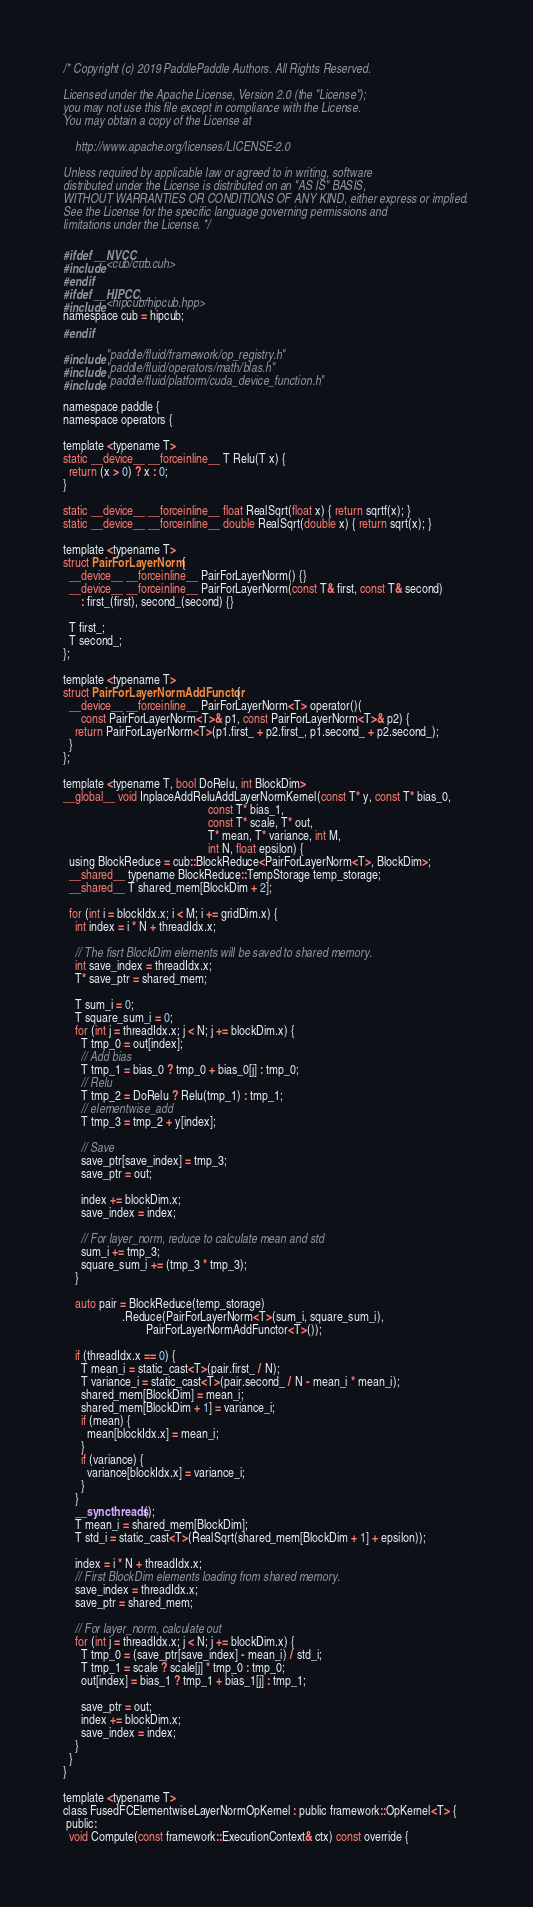<code> <loc_0><loc_0><loc_500><loc_500><_Cuda_>/* Copyright (c) 2019 PaddlePaddle Authors. All Rights Reserved.

Licensed under the Apache License, Version 2.0 (the "License");
you may not use this file except in compliance with the License.
You may obtain a copy of the License at

    http://www.apache.org/licenses/LICENSE-2.0

Unless required by applicable law or agreed to in writing, software
distributed under the License is distributed on an "AS IS" BASIS,
WITHOUT WARRANTIES OR CONDITIONS OF ANY KIND, either express or implied.
See the License for the specific language governing permissions and
limitations under the License. */

#ifdef __NVCC__
#include <cub/cub.cuh>
#endif
#ifdef __HIPCC__
#include <hipcub/hipcub.hpp>
namespace cub = hipcub;
#endif

#include "paddle/fluid/framework/op_registry.h"
#include "paddle/fluid/operators/math/blas.h"
#include "paddle/fluid/platform/cuda_device_function.h"

namespace paddle {
namespace operators {

template <typename T>
static __device__ __forceinline__ T Relu(T x) {
  return (x > 0) ? x : 0;
}

static __device__ __forceinline__ float RealSqrt(float x) { return sqrtf(x); }
static __device__ __forceinline__ double RealSqrt(double x) { return sqrt(x); }

template <typename T>
struct PairForLayerNorm {
  __device__ __forceinline__ PairForLayerNorm() {}
  __device__ __forceinline__ PairForLayerNorm(const T& first, const T& second)
      : first_(first), second_(second) {}

  T first_;
  T second_;
};

template <typename T>
struct PairForLayerNormAddFunctor {
  __device__ __forceinline__ PairForLayerNorm<T> operator()(
      const PairForLayerNorm<T>& p1, const PairForLayerNorm<T>& p2) {
    return PairForLayerNorm<T>(p1.first_ + p2.first_, p1.second_ + p2.second_);
  }
};

template <typename T, bool DoRelu, int BlockDim>
__global__ void InplaceAddReluAddLayerNormKernel(const T* y, const T* bias_0,
                                                 const T* bias_1,
                                                 const T* scale, T* out,
                                                 T* mean, T* variance, int M,
                                                 int N, float epsilon) {
  using BlockReduce = cub::BlockReduce<PairForLayerNorm<T>, BlockDim>;
  __shared__ typename BlockReduce::TempStorage temp_storage;
  __shared__ T shared_mem[BlockDim + 2];

  for (int i = blockIdx.x; i < M; i += gridDim.x) {
    int index = i * N + threadIdx.x;

    // The fisrt BlockDim elements will be saved to shared memory.
    int save_index = threadIdx.x;
    T* save_ptr = shared_mem;

    T sum_i = 0;
    T square_sum_i = 0;
    for (int j = threadIdx.x; j < N; j += blockDim.x) {
      T tmp_0 = out[index];
      // Add bias
      T tmp_1 = bias_0 ? tmp_0 + bias_0[j] : tmp_0;
      // Relu
      T tmp_2 = DoRelu ? Relu(tmp_1) : tmp_1;
      // elementwise_add
      T tmp_3 = tmp_2 + y[index];

      // Save
      save_ptr[save_index] = tmp_3;
      save_ptr = out;

      index += blockDim.x;
      save_index = index;

      // For layer_norm, reduce to calculate mean and std
      sum_i += tmp_3;
      square_sum_i += (tmp_3 * tmp_3);
    }

    auto pair = BlockReduce(temp_storage)
                    .Reduce(PairForLayerNorm<T>(sum_i, square_sum_i),
                            PairForLayerNormAddFunctor<T>());

    if (threadIdx.x == 0) {
      T mean_i = static_cast<T>(pair.first_ / N);
      T variance_i = static_cast<T>(pair.second_ / N - mean_i * mean_i);
      shared_mem[BlockDim] = mean_i;
      shared_mem[BlockDim + 1] = variance_i;
      if (mean) {
        mean[blockIdx.x] = mean_i;
      }
      if (variance) {
        variance[blockIdx.x] = variance_i;
      }
    }
    __syncthreads();
    T mean_i = shared_mem[BlockDim];
    T std_i = static_cast<T>(RealSqrt(shared_mem[BlockDim + 1] + epsilon));

    index = i * N + threadIdx.x;
    // First BlockDim elements loading from shared memory.
    save_index = threadIdx.x;
    save_ptr = shared_mem;

    // For layer_norm, calculate out
    for (int j = threadIdx.x; j < N; j += blockDim.x) {
      T tmp_0 = (save_ptr[save_index] - mean_i) / std_i;
      T tmp_1 = scale ? scale[j] * tmp_0 : tmp_0;
      out[index] = bias_1 ? tmp_1 + bias_1[j] : tmp_1;

      save_ptr = out;
      index += blockDim.x;
      save_index = index;
    }
  }
}

template <typename T>
class FusedFCElementwiseLayerNormOpKernel : public framework::OpKernel<T> {
 public:
  void Compute(const framework::ExecutionContext& ctx) const override {</code> 